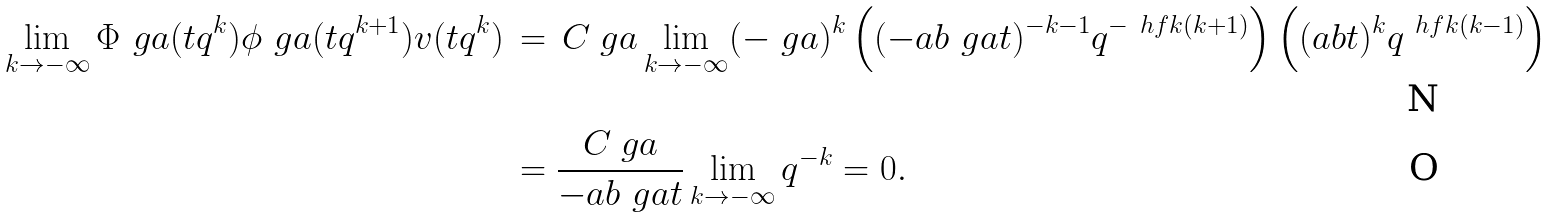<formula> <loc_0><loc_0><loc_500><loc_500>\lim _ { k \to - \infty } \Phi _ { \ } g a ( t q ^ { k } ) \phi _ { \ } g a ( t q ^ { k + 1 } ) v ( t q ^ { k } ) & \, = \, C _ { \ } g a \lim _ { k \to - \infty } ( - \ g a ) ^ { k } \left ( ( - a b \ g a t ) ^ { - k - 1 } q ^ { - \ h f k ( k + 1 ) } \right ) \left ( ( a b t ) ^ { k } q ^ { \ h f k ( k - 1 ) } \right ) \\ & \, = \frac { C _ { \ } g a } { - a b \ g a t } \lim _ { k \to - \infty } q ^ { - k } = 0 .</formula> 